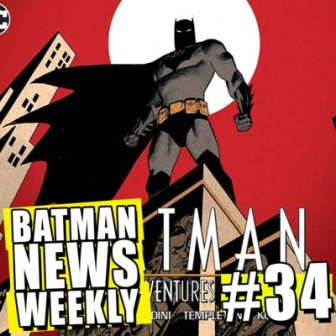In a realistic scenario, imagine Batman preparing to leap off the building. Describe his possible thoughts. Standing on the ledge, Batman's mind is a sharpened steel trap of determination and calculation. Every movement is premeditated, his focus unwavering. He scans the street below, noting the escape routes, potential threats, and where the shadows offer the best cover. His pulse steady, each breath measured. As he crouches, muscles coiled like springs, his thoughts are simple and clear: 'Protect the innocent. Bring justice. Tonight is no different. No hesitation. No failure.' In one fluid motion, he launches himself into the night, a dark guardian of Gotham. 